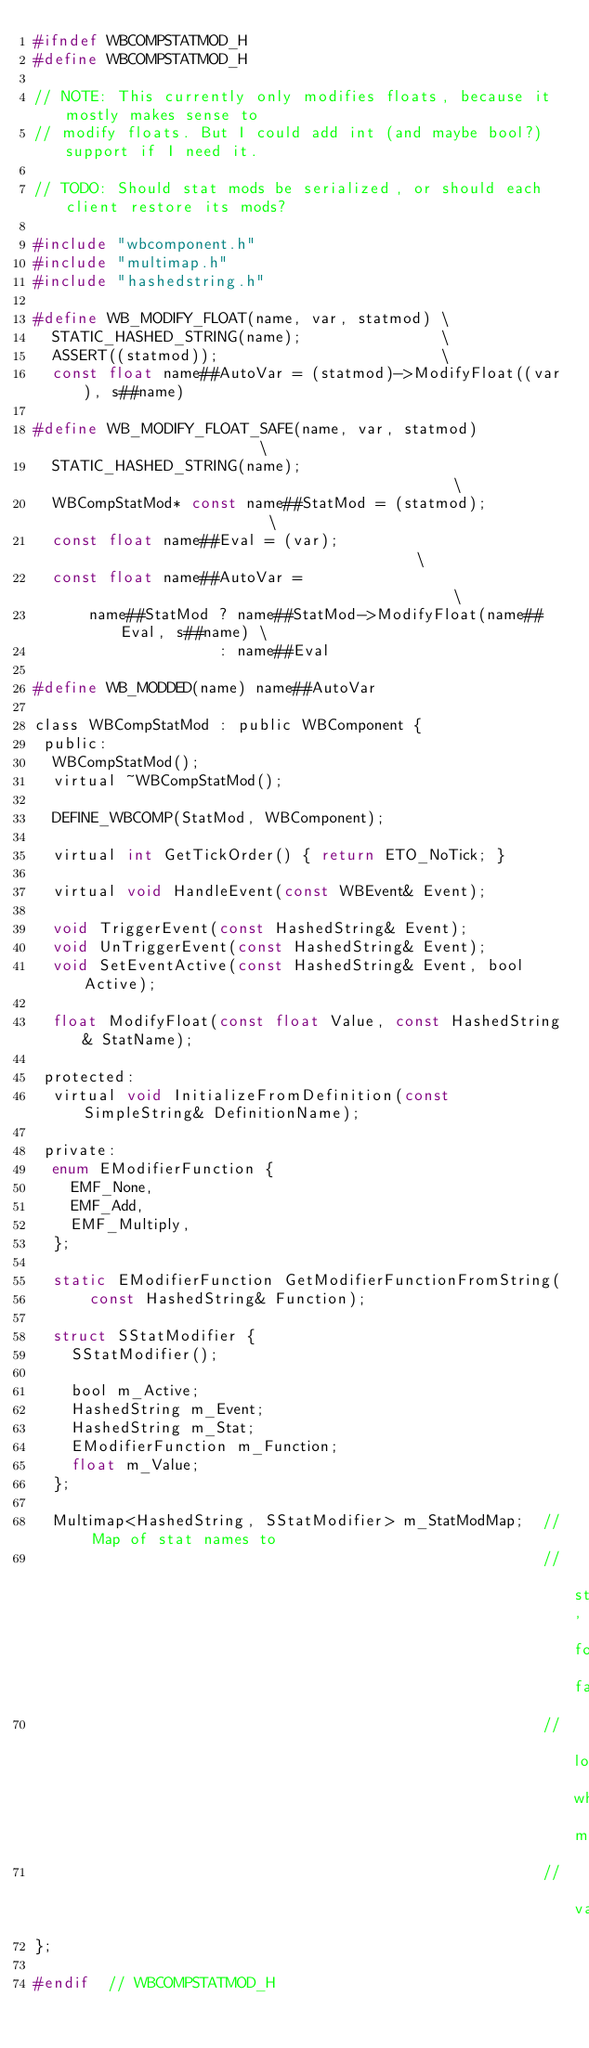Convert code to text. <code><loc_0><loc_0><loc_500><loc_500><_C_>#ifndef WBCOMPSTATMOD_H
#define WBCOMPSTATMOD_H

// NOTE: This currently only modifies floats, because it mostly makes sense to
// modify floats. But I could add int (and maybe bool?) support if I need it.

// TODO: Should stat mods be serialized, or should each client restore its mods?

#include "wbcomponent.h"
#include "multimap.h"
#include "hashedstring.h"

#define WB_MODIFY_FLOAT(name, var, statmod) \
  STATIC_HASHED_STRING(name);               \
  ASSERT((statmod));                        \
  const float name##AutoVar = (statmod)->ModifyFloat((var), s##name)

#define WB_MODIFY_FLOAT_SAFE(name, var, statmod)                      \
  STATIC_HASHED_STRING(name);                                         \
  WBCompStatMod* const name##StatMod = (statmod);                     \
  const float name##Eval = (var);                                     \
  const float name##AutoVar =                                         \
      name##StatMod ? name##StatMod->ModifyFloat(name##Eval, s##name) \
                    : name##Eval

#define WB_MODDED(name) name##AutoVar

class WBCompStatMod : public WBComponent {
 public:
  WBCompStatMod();
  virtual ~WBCompStatMod();

  DEFINE_WBCOMP(StatMod, WBComponent);

  virtual int GetTickOrder() { return ETO_NoTick; }

  virtual void HandleEvent(const WBEvent& Event);

  void TriggerEvent(const HashedString& Event);
  void UnTriggerEvent(const HashedString& Event);
  void SetEventActive(const HashedString& Event, bool Active);

  float ModifyFloat(const float Value, const HashedString& StatName);

 protected:
  virtual void InitializeFromDefinition(const SimpleString& DefinitionName);

 private:
  enum EModifierFunction {
    EMF_None,
    EMF_Add,
    EMF_Multiply,
  };

  static EModifierFunction GetModifierFunctionFromString(
      const HashedString& Function);

  struct SStatModifier {
    SStatModifier();

    bool m_Active;
    HashedString m_Event;
    HashedString m_Stat;
    EModifierFunction m_Function;
    float m_Value;
  };

  Multimap<HashedString, SStatModifier> m_StatModMap;  // Map of stat names to
                                                       // structure, for fastest
                                                       // lookup when modifying
                                                       // value
};

#endif  // WBCOMPSTATMOD_H</code> 